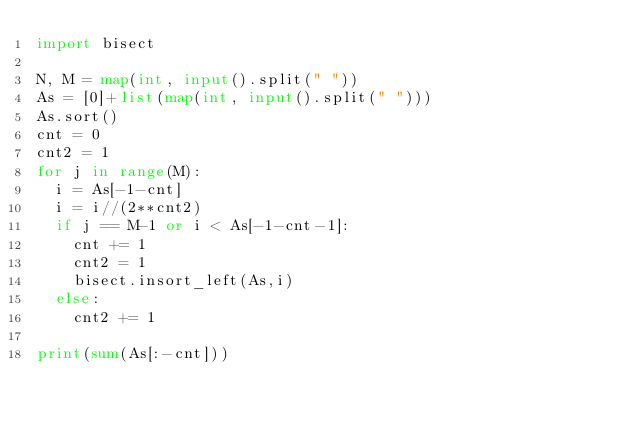<code> <loc_0><loc_0><loc_500><loc_500><_Python_>import bisect
 
N, M = map(int, input().split(" "))
As = [0]+list(map(int, input().split(" ")))
As.sort()
cnt = 0
cnt2 = 1
for j in range(M):
  i = As[-1-cnt]  
  i = i//(2**cnt2)
  if j == M-1 or i < As[-1-cnt-1]:
    cnt += 1
    cnt2 = 1
    bisect.insort_left(As,i)
  else:
    cnt2 += 1
 
print(sum(As[:-cnt]))</code> 